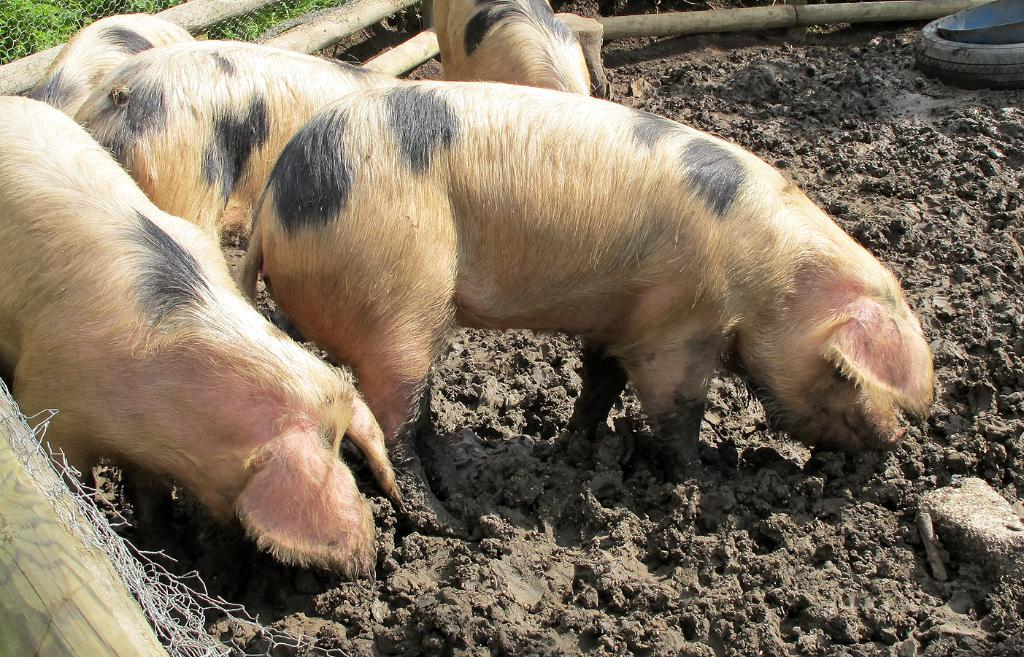What types of living organisms can be seen in the image? There are animals in the image. What is the surface on which the animals are standing? There is ground visible in the image. What object can be seen in the image that is typically used for vehicles? There is a tyre in the image. What container is present in the image? There is a tub in the image. What material can be seen in the image that is commonly used for making objects like toothpicks? There are wooden sticks in the image. What is the purpose of the net in the image? There is a net in the image, which might be used for catching or holding something. What type of vegetation is present in the image? Grass is present in the image. What type of hen can be seen laying eggs in the image? There is no hen or eggs present in the image. 